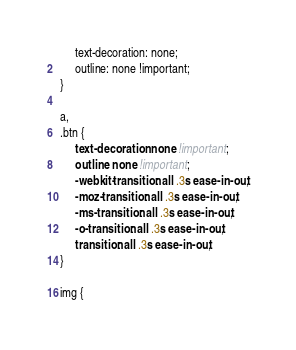Convert code to text. <code><loc_0><loc_0><loc_500><loc_500><_CSS_>     text-decoration: none;
     outline: none !important;
}

a,
.btn {
     text-decoration: none !important;
     outline: none !important;
     -webkit-transition: all .3s ease-in-out;
     -moz-transition: all .3s ease-in-out;
     -ms-transition: all .3s ease-in-out;
     -o-transition: all .3s ease-in-out;
     transition: all .3s ease-in-out;
}

img {</code> 